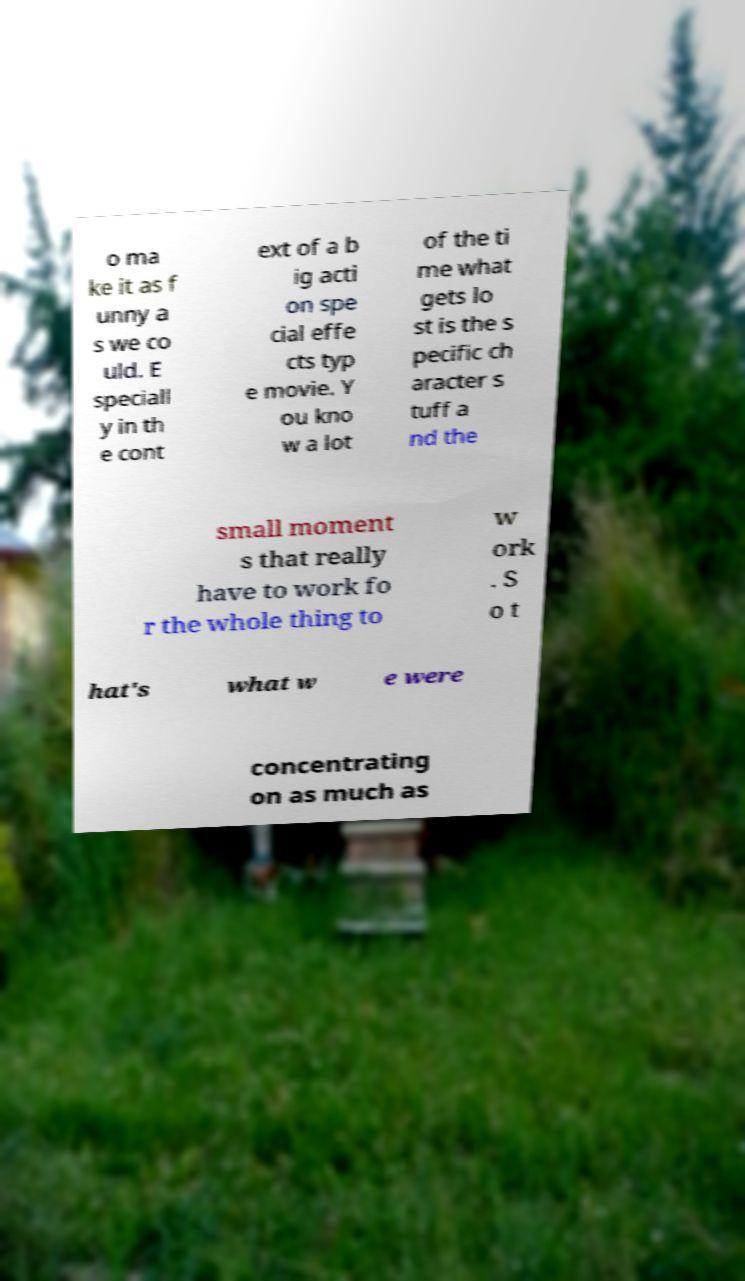Can you read and provide the text displayed in the image?This photo seems to have some interesting text. Can you extract and type it out for me? o ma ke it as f unny a s we co uld. E speciall y in th e cont ext of a b ig acti on spe cial effe cts typ e movie. Y ou kno w a lot of the ti me what gets lo st is the s pecific ch aracter s tuff a nd the small moment s that really have to work fo r the whole thing to w ork . S o t hat's what w e were concentrating on as much as 